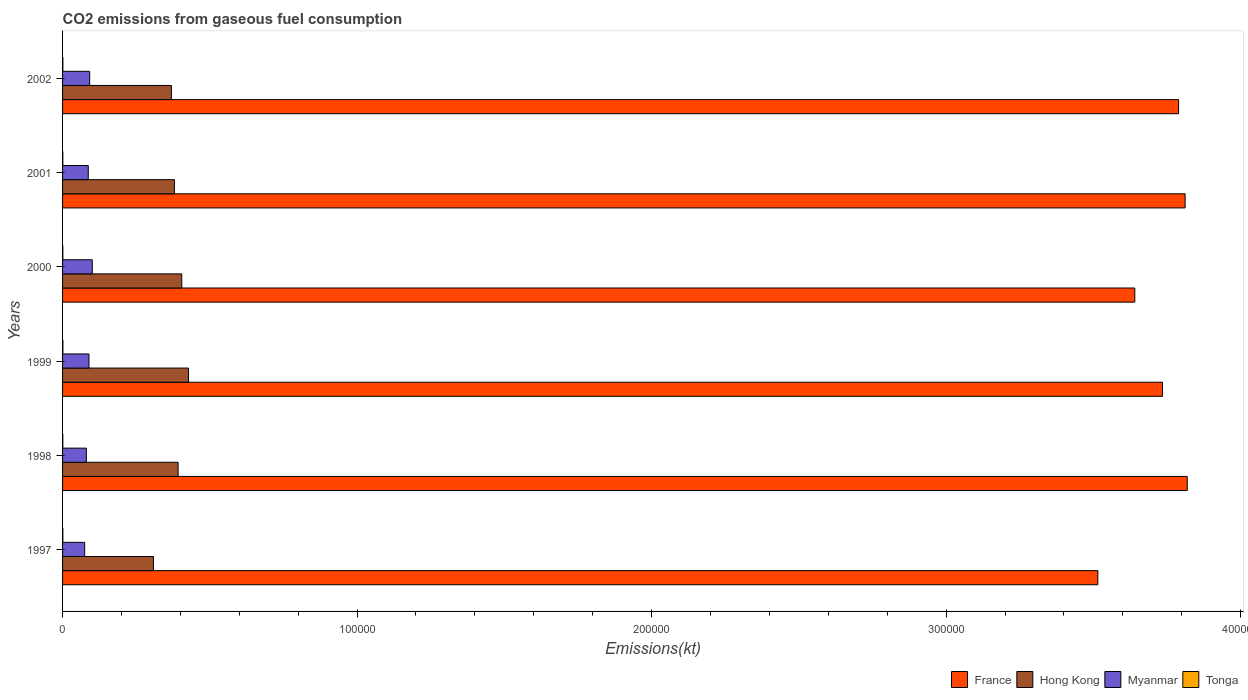How many different coloured bars are there?
Keep it short and to the point. 4. How many bars are there on the 4th tick from the top?
Your answer should be compact. 4. How many bars are there on the 6th tick from the bottom?
Offer a very short reply. 4. What is the label of the 6th group of bars from the top?
Your response must be concise. 1997. In how many cases, is the number of bars for a given year not equal to the number of legend labels?
Provide a short and direct response. 0. What is the amount of CO2 emitted in Myanmar in 2002?
Provide a short and direct response. 9207.84. Across all years, what is the maximum amount of CO2 emitted in Hong Kong?
Provide a short and direct response. 4.28e+04. Across all years, what is the minimum amount of CO2 emitted in Tonga?
Offer a terse response. 88.01. In which year was the amount of CO2 emitted in Hong Kong maximum?
Provide a succinct answer. 1999. In which year was the amount of CO2 emitted in Tonga minimum?
Offer a terse response. 1998. What is the total amount of CO2 emitted in Tonga in the graph?
Provide a succinct answer. 583.05. What is the difference between the amount of CO2 emitted in France in 1999 and that in 2002?
Give a very brief answer. -5467.5. What is the difference between the amount of CO2 emitted in Tonga in 1999 and the amount of CO2 emitted in France in 2002?
Your answer should be very brief. -3.79e+05. What is the average amount of CO2 emitted in Myanmar per year?
Keep it short and to the point. 8761.07. In the year 1998, what is the difference between the amount of CO2 emitted in Hong Kong and amount of CO2 emitted in France?
Offer a very short reply. -3.43e+05. What is the ratio of the amount of CO2 emitted in France in 2001 to that in 2002?
Give a very brief answer. 1.01. Is the amount of CO2 emitted in France in 1999 less than that in 2000?
Provide a short and direct response. No. What is the difference between the highest and the second highest amount of CO2 emitted in France?
Ensure brevity in your answer.  722.4. What is the difference between the highest and the lowest amount of CO2 emitted in Hong Kong?
Provide a succinct answer. 1.19e+04. Is the sum of the amount of CO2 emitted in Myanmar in 1998 and 2002 greater than the maximum amount of CO2 emitted in Hong Kong across all years?
Your answer should be very brief. No. Is it the case that in every year, the sum of the amount of CO2 emitted in Tonga and amount of CO2 emitted in France is greater than the sum of amount of CO2 emitted in Myanmar and amount of CO2 emitted in Hong Kong?
Provide a succinct answer. No. What does the 2nd bar from the top in 2000 represents?
Provide a succinct answer. Myanmar. What does the 2nd bar from the bottom in 2001 represents?
Ensure brevity in your answer.  Hong Kong. How many bars are there?
Keep it short and to the point. 24. Are all the bars in the graph horizontal?
Offer a very short reply. Yes. How many years are there in the graph?
Ensure brevity in your answer.  6. Does the graph contain any zero values?
Your answer should be very brief. No. Does the graph contain grids?
Your answer should be very brief. No. What is the title of the graph?
Your answer should be compact. CO2 emissions from gaseous fuel consumption. Does "Gabon" appear as one of the legend labels in the graph?
Offer a very short reply. No. What is the label or title of the X-axis?
Offer a very short reply. Emissions(kt). What is the Emissions(kt) in France in 1997?
Your answer should be compact. 3.52e+05. What is the Emissions(kt) in Hong Kong in 1997?
Provide a succinct answer. 3.09e+04. What is the Emissions(kt) of Myanmar in 1997?
Keep it short and to the point. 7499.02. What is the Emissions(kt) of Tonga in 1997?
Offer a very short reply. 99.01. What is the Emissions(kt) of France in 1998?
Your response must be concise. 3.82e+05. What is the Emissions(kt) of Hong Kong in 1998?
Your answer should be very brief. 3.92e+04. What is the Emissions(kt) in Myanmar in 1998?
Keep it short and to the point. 8078.4. What is the Emissions(kt) of Tonga in 1998?
Give a very brief answer. 88.01. What is the Emissions(kt) of France in 1999?
Your answer should be very brief. 3.73e+05. What is the Emissions(kt) of Hong Kong in 1999?
Provide a succinct answer. 4.28e+04. What is the Emissions(kt) of Myanmar in 1999?
Your answer should be very brief. 8969.48. What is the Emissions(kt) of Tonga in 1999?
Keep it short and to the point. 110.01. What is the Emissions(kt) of France in 2000?
Your answer should be very brief. 3.64e+05. What is the Emissions(kt) in Hong Kong in 2000?
Keep it short and to the point. 4.05e+04. What is the Emissions(kt) of Myanmar in 2000?
Offer a terse response. 1.01e+04. What is the Emissions(kt) of Tonga in 2000?
Offer a very short reply. 95.34. What is the Emissions(kt) of France in 2001?
Keep it short and to the point. 3.81e+05. What is the Emissions(kt) of Hong Kong in 2001?
Offer a terse response. 3.80e+04. What is the Emissions(kt) in Myanmar in 2001?
Your answer should be compact. 8723.79. What is the Emissions(kt) of Tonga in 2001?
Offer a terse response. 88.01. What is the Emissions(kt) in France in 2002?
Give a very brief answer. 3.79e+05. What is the Emissions(kt) in Hong Kong in 2002?
Your response must be concise. 3.70e+04. What is the Emissions(kt) in Myanmar in 2002?
Your answer should be very brief. 9207.84. What is the Emissions(kt) in Tonga in 2002?
Ensure brevity in your answer.  102.68. Across all years, what is the maximum Emissions(kt) in France?
Provide a succinct answer. 3.82e+05. Across all years, what is the maximum Emissions(kt) in Hong Kong?
Your answer should be compact. 4.28e+04. Across all years, what is the maximum Emissions(kt) in Myanmar?
Offer a very short reply. 1.01e+04. Across all years, what is the maximum Emissions(kt) of Tonga?
Provide a short and direct response. 110.01. Across all years, what is the minimum Emissions(kt) of France?
Offer a terse response. 3.52e+05. Across all years, what is the minimum Emissions(kt) of Hong Kong?
Your answer should be very brief. 3.09e+04. Across all years, what is the minimum Emissions(kt) in Myanmar?
Provide a short and direct response. 7499.02. Across all years, what is the minimum Emissions(kt) in Tonga?
Ensure brevity in your answer.  88.01. What is the total Emissions(kt) in France in the graph?
Provide a succinct answer. 2.23e+06. What is the total Emissions(kt) of Hong Kong in the graph?
Provide a succinct answer. 2.28e+05. What is the total Emissions(kt) of Myanmar in the graph?
Provide a succinct answer. 5.26e+04. What is the total Emissions(kt) in Tonga in the graph?
Provide a succinct answer. 583.05. What is the difference between the Emissions(kt) in France in 1997 and that in 1998?
Keep it short and to the point. -3.04e+04. What is the difference between the Emissions(kt) in Hong Kong in 1997 and that in 1998?
Offer a terse response. -8379.09. What is the difference between the Emissions(kt) of Myanmar in 1997 and that in 1998?
Offer a terse response. -579.39. What is the difference between the Emissions(kt) of Tonga in 1997 and that in 1998?
Your answer should be compact. 11. What is the difference between the Emissions(kt) of France in 1997 and that in 1999?
Offer a terse response. -2.20e+04. What is the difference between the Emissions(kt) in Hong Kong in 1997 and that in 1999?
Provide a short and direct response. -1.19e+04. What is the difference between the Emissions(kt) in Myanmar in 1997 and that in 1999?
Keep it short and to the point. -1470.47. What is the difference between the Emissions(kt) in Tonga in 1997 and that in 1999?
Provide a succinct answer. -11. What is the difference between the Emissions(kt) of France in 1997 and that in 2000?
Your response must be concise. -1.26e+04. What is the difference between the Emissions(kt) of Hong Kong in 1997 and that in 2000?
Make the answer very short. -9611.21. What is the difference between the Emissions(kt) of Myanmar in 1997 and that in 2000?
Keep it short and to the point. -2588.9. What is the difference between the Emissions(kt) in Tonga in 1997 and that in 2000?
Keep it short and to the point. 3.67. What is the difference between the Emissions(kt) of France in 1997 and that in 2001?
Make the answer very short. -2.96e+04. What is the difference between the Emissions(kt) in Hong Kong in 1997 and that in 2001?
Your response must be concise. -7117.65. What is the difference between the Emissions(kt) in Myanmar in 1997 and that in 2001?
Keep it short and to the point. -1224.78. What is the difference between the Emissions(kt) in Tonga in 1997 and that in 2001?
Offer a very short reply. 11. What is the difference between the Emissions(kt) of France in 1997 and that in 2002?
Make the answer very short. -2.74e+04. What is the difference between the Emissions(kt) in Hong Kong in 1997 and that in 2002?
Offer a terse response. -6098.22. What is the difference between the Emissions(kt) of Myanmar in 1997 and that in 2002?
Offer a terse response. -1708.82. What is the difference between the Emissions(kt) in Tonga in 1997 and that in 2002?
Make the answer very short. -3.67. What is the difference between the Emissions(kt) in France in 1998 and that in 1999?
Your answer should be compact. 8415.76. What is the difference between the Emissions(kt) in Hong Kong in 1998 and that in 1999?
Make the answer very short. -3520.32. What is the difference between the Emissions(kt) in Myanmar in 1998 and that in 1999?
Make the answer very short. -891.08. What is the difference between the Emissions(kt) in Tonga in 1998 and that in 1999?
Give a very brief answer. -22. What is the difference between the Emissions(kt) of France in 1998 and that in 2000?
Your response must be concise. 1.78e+04. What is the difference between the Emissions(kt) of Hong Kong in 1998 and that in 2000?
Your response must be concise. -1232.11. What is the difference between the Emissions(kt) in Myanmar in 1998 and that in 2000?
Provide a succinct answer. -2009.52. What is the difference between the Emissions(kt) of Tonga in 1998 and that in 2000?
Your answer should be very brief. -7.33. What is the difference between the Emissions(kt) in France in 1998 and that in 2001?
Your response must be concise. 722.4. What is the difference between the Emissions(kt) of Hong Kong in 1998 and that in 2001?
Ensure brevity in your answer.  1261.45. What is the difference between the Emissions(kt) in Myanmar in 1998 and that in 2001?
Your answer should be compact. -645.39. What is the difference between the Emissions(kt) in Tonga in 1998 and that in 2001?
Your answer should be very brief. 0. What is the difference between the Emissions(kt) in France in 1998 and that in 2002?
Make the answer very short. 2948.27. What is the difference between the Emissions(kt) in Hong Kong in 1998 and that in 2002?
Keep it short and to the point. 2280.87. What is the difference between the Emissions(kt) in Myanmar in 1998 and that in 2002?
Offer a terse response. -1129.44. What is the difference between the Emissions(kt) in Tonga in 1998 and that in 2002?
Give a very brief answer. -14.67. What is the difference between the Emissions(kt) of France in 1999 and that in 2000?
Offer a terse response. 9398.52. What is the difference between the Emissions(kt) in Hong Kong in 1999 and that in 2000?
Provide a short and direct response. 2288.21. What is the difference between the Emissions(kt) of Myanmar in 1999 and that in 2000?
Provide a short and direct response. -1118.43. What is the difference between the Emissions(kt) in Tonga in 1999 and that in 2000?
Offer a very short reply. 14.67. What is the difference between the Emissions(kt) in France in 1999 and that in 2001?
Offer a very short reply. -7693.37. What is the difference between the Emissions(kt) in Hong Kong in 1999 and that in 2001?
Offer a very short reply. 4781.77. What is the difference between the Emissions(kt) in Myanmar in 1999 and that in 2001?
Offer a very short reply. 245.69. What is the difference between the Emissions(kt) of Tonga in 1999 and that in 2001?
Provide a short and direct response. 22. What is the difference between the Emissions(kt) of France in 1999 and that in 2002?
Keep it short and to the point. -5467.5. What is the difference between the Emissions(kt) of Hong Kong in 1999 and that in 2002?
Ensure brevity in your answer.  5801.19. What is the difference between the Emissions(kt) in Myanmar in 1999 and that in 2002?
Your answer should be compact. -238.35. What is the difference between the Emissions(kt) of Tonga in 1999 and that in 2002?
Offer a terse response. 7.33. What is the difference between the Emissions(kt) of France in 2000 and that in 2001?
Your answer should be very brief. -1.71e+04. What is the difference between the Emissions(kt) in Hong Kong in 2000 and that in 2001?
Ensure brevity in your answer.  2493.56. What is the difference between the Emissions(kt) of Myanmar in 2000 and that in 2001?
Ensure brevity in your answer.  1364.12. What is the difference between the Emissions(kt) of Tonga in 2000 and that in 2001?
Your response must be concise. 7.33. What is the difference between the Emissions(kt) in France in 2000 and that in 2002?
Provide a succinct answer. -1.49e+04. What is the difference between the Emissions(kt) of Hong Kong in 2000 and that in 2002?
Offer a terse response. 3512.99. What is the difference between the Emissions(kt) in Myanmar in 2000 and that in 2002?
Ensure brevity in your answer.  880.08. What is the difference between the Emissions(kt) of Tonga in 2000 and that in 2002?
Provide a short and direct response. -7.33. What is the difference between the Emissions(kt) of France in 2001 and that in 2002?
Make the answer very short. 2225.87. What is the difference between the Emissions(kt) in Hong Kong in 2001 and that in 2002?
Make the answer very short. 1019.43. What is the difference between the Emissions(kt) in Myanmar in 2001 and that in 2002?
Your response must be concise. -484.04. What is the difference between the Emissions(kt) of Tonga in 2001 and that in 2002?
Your response must be concise. -14.67. What is the difference between the Emissions(kt) of France in 1997 and the Emissions(kt) of Hong Kong in 1998?
Your answer should be very brief. 3.12e+05. What is the difference between the Emissions(kt) in France in 1997 and the Emissions(kt) in Myanmar in 1998?
Your answer should be very brief. 3.43e+05. What is the difference between the Emissions(kt) of France in 1997 and the Emissions(kt) of Tonga in 1998?
Your answer should be very brief. 3.51e+05. What is the difference between the Emissions(kt) of Hong Kong in 1997 and the Emissions(kt) of Myanmar in 1998?
Your answer should be very brief. 2.28e+04. What is the difference between the Emissions(kt) of Hong Kong in 1997 and the Emissions(kt) of Tonga in 1998?
Give a very brief answer. 3.08e+04. What is the difference between the Emissions(kt) in Myanmar in 1997 and the Emissions(kt) in Tonga in 1998?
Offer a terse response. 7411.01. What is the difference between the Emissions(kt) in France in 1997 and the Emissions(kt) in Hong Kong in 1999?
Keep it short and to the point. 3.09e+05. What is the difference between the Emissions(kt) of France in 1997 and the Emissions(kt) of Myanmar in 1999?
Provide a succinct answer. 3.43e+05. What is the difference between the Emissions(kt) in France in 1997 and the Emissions(kt) in Tonga in 1999?
Ensure brevity in your answer.  3.51e+05. What is the difference between the Emissions(kt) in Hong Kong in 1997 and the Emissions(kt) in Myanmar in 1999?
Give a very brief answer. 2.19e+04. What is the difference between the Emissions(kt) of Hong Kong in 1997 and the Emissions(kt) of Tonga in 1999?
Give a very brief answer. 3.07e+04. What is the difference between the Emissions(kt) in Myanmar in 1997 and the Emissions(kt) in Tonga in 1999?
Your response must be concise. 7389.01. What is the difference between the Emissions(kt) in France in 1997 and the Emissions(kt) in Hong Kong in 2000?
Your answer should be very brief. 3.11e+05. What is the difference between the Emissions(kt) of France in 1997 and the Emissions(kt) of Myanmar in 2000?
Give a very brief answer. 3.41e+05. What is the difference between the Emissions(kt) of France in 1997 and the Emissions(kt) of Tonga in 2000?
Offer a very short reply. 3.51e+05. What is the difference between the Emissions(kt) of Hong Kong in 1997 and the Emissions(kt) of Myanmar in 2000?
Your answer should be very brief. 2.08e+04. What is the difference between the Emissions(kt) in Hong Kong in 1997 and the Emissions(kt) in Tonga in 2000?
Keep it short and to the point. 3.08e+04. What is the difference between the Emissions(kt) of Myanmar in 1997 and the Emissions(kt) of Tonga in 2000?
Make the answer very short. 7403.67. What is the difference between the Emissions(kt) in France in 1997 and the Emissions(kt) in Hong Kong in 2001?
Keep it short and to the point. 3.14e+05. What is the difference between the Emissions(kt) in France in 1997 and the Emissions(kt) in Myanmar in 2001?
Your answer should be compact. 3.43e+05. What is the difference between the Emissions(kt) in France in 1997 and the Emissions(kt) in Tonga in 2001?
Keep it short and to the point. 3.51e+05. What is the difference between the Emissions(kt) in Hong Kong in 1997 and the Emissions(kt) in Myanmar in 2001?
Your answer should be very brief. 2.21e+04. What is the difference between the Emissions(kt) in Hong Kong in 1997 and the Emissions(kt) in Tonga in 2001?
Offer a terse response. 3.08e+04. What is the difference between the Emissions(kt) of Myanmar in 1997 and the Emissions(kt) of Tonga in 2001?
Your answer should be compact. 7411.01. What is the difference between the Emissions(kt) in France in 1997 and the Emissions(kt) in Hong Kong in 2002?
Ensure brevity in your answer.  3.15e+05. What is the difference between the Emissions(kt) in France in 1997 and the Emissions(kt) in Myanmar in 2002?
Your answer should be compact. 3.42e+05. What is the difference between the Emissions(kt) in France in 1997 and the Emissions(kt) in Tonga in 2002?
Keep it short and to the point. 3.51e+05. What is the difference between the Emissions(kt) of Hong Kong in 1997 and the Emissions(kt) of Myanmar in 2002?
Your response must be concise. 2.16e+04. What is the difference between the Emissions(kt) in Hong Kong in 1997 and the Emissions(kt) in Tonga in 2002?
Keep it short and to the point. 3.08e+04. What is the difference between the Emissions(kt) in Myanmar in 1997 and the Emissions(kt) in Tonga in 2002?
Provide a short and direct response. 7396.34. What is the difference between the Emissions(kt) in France in 1998 and the Emissions(kt) in Hong Kong in 1999?
Provide a succinct answer. 3.39e+05. What is the difference between the Emissions(kt) of France in 1998 and the Emissions(kt) of Myanmar in 1999?
Provide a short and direct response. 3.73e+05. What is the difference between the Emissions(kt) of France in 1998 and the Emissions(kt) of Tonga in 1999?
Your answer should be compact. 3.82e+05. What is the difference between the Emissions(kt) of Hong Kong in 1998 and the Emissions(kt) of Myanmar in 1999?
Ensure brevity in your answer.  3.03e+04. What is the difference between the Emissions(kt) in Hong Kong in 1998 and the Emissions(kt) in Tonga in 1999?
Ensure brevity in your answer.  3.91e+04. What is the difference between the Emissions(kt) of Myanmar in 1998 and the Emissions(kt) of Tonga in 1999?
Offer a very short reply. 7968.39. What is the difference between the Emissions(kt) in France in 1998 and the Emissions(kt) in Hong Kong in 2000?
Your answer should be compact. 3.41e+05. What is the difference between the Emissions(kt) in France in 1998 and the Emissions(kt) in Myanmar in 2000?
Offer a terse response. 3.72e+05. What is the difference between the Emissions(kt) in France in 1998 and the Emissions(kt) in Tonga in 2000?
Provide a short and direct response. 3.82e+05. What is the difference between the Emissions(kt) of Hong Kong in 1998 and the Emissions(kt) of Myanmar in 2000?
Offer a terse response. 2.91e+04. What is the difference between the Emissions(kt) of Hong Kong in 1998 and the Emissions(kt) of Tonga in 2000?
Keep it short and to the point. 3.91e+04. What is the difference between the Emissions(kt) of Myanmar in 1998 and the Emissions(kt) of Tonga in 2000?
Your answer should be very brief. 7983.06. What is the difference between the Emissions(kt) in France in 1998 and the Emissions(kt) in Hong Kong in 2001?
Make the answer very short. 3.44e+05. What is the difference between the Emissions(kt) in France in 1998 and the Emissions(kt) in Myanmar in 2001?
Give a very brief answer. 3.73e+05. What is the difference between the Emissions(kt) of France in 1998 and the Emissions(kt) of Tonga in 2001?
Your answer should be compact. 3.82e+05. What is the difference between the Emissions(kt) in Hong Kong in 1998 and the Emissions(kt) in Myanmar in 2001?
Your answer should be compact. 3.05e+04. What is the difference between the Emissions(kt) of Hong Kong in 1998 and the Emissions(kt) of Tonga in 2001?
Ensure brevity in your answer.  3.91e+04. What is the difference between the Emissions(kt) of Myanmar in 1998 and the Emissions(kt) of Tonga in 2001?
Provide a succinct answer. 7990.39. What is the difference between the Emissions(kt) in France in 1998 and the Emissions(kt) in Hong Kong in 2002?
Ensure brevity in your answer.  3.45e+05. What is the difference between the Emissions(kt) in France in 1998 and the Emissions(kt) in Myanmar in 2002?
Make the answer very short. 3.73e+05. What is the difference between the Emissions(kt) in France in 1998 and the Emissions(kt) in Tonga in 2002?
Provide a short and direct response. 3.82e+05. What is the difference between the Emissions(kt) in Hong Kong in 1998 and the Emissions(kt) in Myanmar in 2002?
Give a very brief answer. 3.00e+04. What is the difference between the Emissions(kt) of Hong Kong in 1998 and the Emissions(kt) of Tonga in 2002?
Make the answer very short. 3.91e+04. What is the difference between the Emissions(kt) in Myanmar in 1998 and the Emissions(kt) in Tonga in 2002?
Provide a short and direct response. 7975.73. What is the difference between the Emissions(kt) in France in 1999 and the Emissions(kt) in Hong Kong in 2000?
Offer a terse response. 3.33e+05. What is the difference between the Emissions(kt) of France in 1999 and the Emissions(kt) of Myanmar in 2000?
Your answer should be very brief. 3.63e+05. What is the difference between the Emissions(kt) of France in 1999 and the Emissions(kt) of Tonga in 2000?
Provide a short and direct response. 3.73e+05. What is the difference between the Emissions(kt) of Hong Kong in 1999 and the Emissions(kt) of Myanmar in 2000?
Your answer should be compact. 3.27e+04. What is the difference between the Emissions(kt) of Hong Kong in 1999 and the Emissions(kt) of Tonga in 2000?
Offer a very short reply. 4.27e+04. What is the difference between the Emissions(kt) in Myanmar in 1999 and the Emissions(kt) in Tonga in 2000?
Your answer should be very brief. 8874.14. What is the difference between the Emissions(kt) of France in 1999 and the Emissions(kt) of Hong Kong in 2001?
Your answer should be compact. 3.35e+05. What is the difference between the Emissions(kt) in France in 1999 and the Emissions(kt) in Myanmar in 2001?
Provide a short and direct response. 3.65e+05. What is the difference between the Emissions(kt) in France in 1999 and the Emissions(kt) in Tonga in 2001?
Offer a terse response. 3.73e+05. What is the difference between the Emissions(kt) of Hong Kong in 1999 and the Emissions(kt) of Myanmar in 2001?
Your answer should be compact. 3.40e+04. What is the difference between the Emissions(kt) of Hong Kong in 1999 and the Emissions(kt) of Tonga in 2001?
Your response must be concise. 4.27e+04. What is the difference between the Emissions(kt) of Myanmar in 1999 and the Emissions(kt) of Tonga in 2001?
Provide a short and direct response. 8881.47. What is the difference between the Emissions(kt) in France in 1999 and the Emissions(kt) in Hong Kong in 2002?
Provide a succinct answer. 3.37e+05. What is the difference between the Emissions(kt) in France in 1999 and the Emissions(kt) in Myanmar in 2002?
Ensure brevity in your answer.  3.64e+05. What is the difference between the Emissions(kt) of France in 1999 and the Emissions(kt) of Tonga in 2002?
Your answer should be very brief. 3.73e+05. What is the difference between the Emissions(kt) of Hong Kong in 1999 and the Emissions(kt) of Myanmar in 2002?
Your answer should be very brief. 3.35e+04. What is the difference between the Emissions(kt) in Hong Kong in 1999 and the Emissions(kt) in Tonga in 2002?
Make the answer very short. 4.27e+04. What is the difference between the Emissions(kt) in Myanmar in 1999 and the Emissions(kt) in Tonga in 2002?
Your answer should be compact. 8866.81. What is the difference between the Emissions(kt) in France in 2000 and the Emissions(kt) in Hong Kong in 2001?
Offer a very short reply. 3.26e+05. What is the difference between the Emissions(kt) of France in 2000 and the Emissions(kt) of Myanmar in 2001?
Keep it short and to the point. 3.55e+05. What is the difference between the Emissions(kt) in France in 2000 and the Emissions(kt) in Tonga in 2001?
Give a very brief answer. 3.64e+05. What is the difference between the Emissions(kt) in Hong Kong in 2000 and the Emissions(kt) in Myanmar in 2001?
Keep it short and to the point. 3.17e+04. What is the difference between the Emissions(kt) of Hong Kong in 2000 and the Emissions(kt) of Tonga in 2001?
Provide a short and direct response. 4.04e+04. What is the difference between the Emissions(kt) of Myanmar in 2000 and the Emissions(kt) of Tonga in 2001?
Your response must be concise. 9999.91. What is the difference between the Emissions(kt) of France in 2000 and the Emissions(kt) of Hong Kong in 2002?
Provide a short and direct response. 3.27e+05. What is the difference between the Emissions(kt) of France in 2000 and the Emissions(kt) of Myanmar in 2002?
Offer a very short reply. 3.55e+05. What is the difference between the Emissions(kt) of France in 2000 and the Emissions(kt) of Tonga in 2002?
Your response must be concise. 3.64e+05. What is the difference between the Emissions(kt) in Hong Kong in 2000 and the Emissions(kt) in Myanmar in 2002?
Give a very brief answer. 3.13e+04. What is the difference between the Emissions(kt) of Hong Kong in 2000 and the Emissions(kt) of Tonga in 2002?
Keep it short and to the point. 4.04e+04. What is the difference between the Emissions(kt) in Myanmar in 2000 and the Emissions(kt) in Tonga in 2002?
Provide a short and direct response. 9985.24. What is the difference between the Emissions(kt) of France in 2001 and the Emissions(kt) of Hong Kong in 2002?
Provide a succinct answer. 3.44e+05. What is the difference between the Emissions(kt) of France in 2001 and the Emissions(kt) of Myanmar in 2002?
Provide a short and direct response. 3.72e+05. What is the difference between the Emissions(kt) of France in 2001 and the Emissions(kt) of Tonga in 2002?
Your answer should be compact. 3.81e+05. What is the difference between the Emissions(kt) of Hong Kong in 2001 and the Emissions(kt) of Myanmar in 2002?
Offer a terse response. 2.88e+04. What is the difference between the Emissions(kt) in Hong Kong in 2001 and the Emissions(kt) in Tonga in 2002?
Provide a succinct answer. 3.79e+04. What is the difference between the Emissions(kt) in Myanmar in 2001 and the Emissions(kt) in Tonga in 2002?
Your answer should be very brief. 8621.12. What is the average Emissions(kt) of France per year?
Keep it short and to the point. 3.72e+05. What is the average Emissions(kt) in Hong Kong per year?
Provide a succinct answer. 3.80e+04. What is the average Emissions(kt) of Myanmar per year?
Make the answer very short. 8761.07. What is the average Emissions(kt) of Tonga per year?
Keep it short and to the point. 97.18. In the year 1997, what is the difference between the Emissions(kt) in France and Emissions(kt) in Hong Kong?
Give a very brief answer. 3.21e+05. In the year 1997, what is the difference between the Emissions(kt) in France and Emissions(kt) in Myanmar?
Offer a terse response. 3.44e+05. In the year 1997, what is the difference between the Emissions(kt) of France and Emissions(kt) of Tonga?
Ensure brevity in your answer.  3.51e+05. In the year 1997, what is the difference between the Emissions(kt) of Hong Kong and Emissions(kt) of Myanmar?
Give a very brief answer. 2.34e+04. In the year 1997, what is the difference between the Emissions(kt) of Hong Kong and Emissions(kt) of Tonga?
Provide a succinct answer. 3.08e+04. In the year 1997, what is the difference between the Emissions(kt) in Myanmar and Emissions(kt) in Tonga?
Ensure brevity in your answer.  7400.01. In the year 1998, what is the difference between the Emissions(kt) in France and Emissions(kt) in Hong Kong?
Your response must be concise. 3.43e+05. In the year 1998, what is the difference between the Emissions(kt) in France and Emissions(kt) in Myanmar?
Your answer should be compact. 3.74e+05. In the year 1998, what is the difference between the Emissions(kt) of France and Emissions(kt) of Tonga?
Give a very brief answer. 3.82e+05. In the year 1998, what is the difference between the Emissions(kt) of Hong Kong and Emissions(kt) of Myanmar?
Your answer should be compact. 3.12e+04. In the year 1998, what is the difference between the Emissions(kt) of Hong Kong and Emissions(kt) of Tonga?
Your response must be concise. 3.91e+04. In the year 1998, what is the difference between the Emissions(kt) in Myanmar and Emissions(kt) in Tonga?
Your answer should be compact. 7990.39. In the year 1999, what is the difference between the Emissions(kt) of France and Emissions(kt) of Hong Kong?
Provide a short and direct response. 3.31e+05. In the year 1999, what is the difference between the Emissions(kt) in France and Emissions(kt) in Myanmar?
Ensure brevity in your answer.  3.64e+05. In the year 1999, what is the difference between the Emissions(kt) of France and Emissions(kt) of Tonga?
Ensure brevity in your answer.  3.73e+05. In the year 1999, what is the difference between the Emissions(kt) of Hong Kong and Emissions(kt) of Myanmar?
Provide a succinct answer. 3.38e+04. In the year 1999, what is the difference between the Emissions(kt) of Hong Kong and Emissions(kt) of Tonga?
Give a very brief answer. 4.26e+04. In the year 1999, what is the difference between the Emissions(kt) in Myanmar and Emissions(kt) in Tonga?
Your answer should be compact. 8859.47. In the year 2000, what is the difference between the Emissions(kt) in France and Emissions(kt) in Hong Kong?
Your response must be concise. 3.24e+05. In the year 2000, what is the difference between the Emissions(kt) of France and Emissions(kt) of Myanmar?
Your answer should be very brief. 3.54e+05. In the year 2000, what is the difference between the Emissions(kt) in France and Emissions(kt) in Tonga?
Offer a very short reply. 3.64e+05. In the year 2000, what is the difference between the Emissions(kt) in Hong Kong and Emissions(kt) in Myanmar?
Make the answer very short. 3.04e+04. In the year 2000, what is the difference between the Emissions(kt) in Hong Kong and Emissions(kt) in Tonga?
Offer a terse response. 4.04e+04. In the year 2000, what is the difference between the Emissions(kt) of Myanmar and Emissions(kt) of Tonga?
Provide a short and direct response. 9992.58. In the year 2001, what is the difference between the Emissions(kt) in France and Emissions(kt) in Hong Kong?
Ensure brevity in your answer.  3.43e+05. In the year 2001, what is the difference between the Emissions(kt) in France and Emissions(kt) in Myanmar?
Give a very brief answer. 3.72e+05. In the year 2001, what is the difference between the Emissions(kt) of France and Emissions(kt) of Tonga?
Offer a terse response. 3.81e+05. In the year 2001, what is the difference between the Emissions(kt) of Hong Kong and Emissions(kt) of Myanmar?
Give a very brief answer. 2.92e+04. In the year 2001, what is the difference between the Emissions(kt) in Hong Kong and Emissions(kt) in Tonga?
Make the answer very short. 3.79e+04. In the year 2001, what is the difference between the Emissions(kt) of Myanmar and Emissions(kt) of Tonga?
Offer a terse response. 8635.78. In the year 2002, what is the difference between the Emissions(kt) in France and Emissions(kt) in Hong Kong?
Offer a terse response. 3.42e+05. In the year 2002, what is the difference between the Emissions(kt) in France and Emissions(kt) in Myanmar?
Your answer should be very brief. 3.70e+05. In the year 2002, what is the difference between the Emissions(kt) of France and Emissions(kt) of Tonga?
Give a very brief answer. 3.79e+05. In the year 2002, what is the difference between the Emissions(kt) of Hong Kong and Emissions(kt) of Myanmar?
Offer a terse response. 2.77e+04. In the year 2002, what is the difference between the Emissions(kt) in Hong Kong and Emissions(kt) in Tonga?
Ensure brevity in your answer.  3.68e+04. In the year 2002, what is the difference between the Emissions(kt) in Myanmar and Emissions(kt) in Tonga?
Provide a short and direct response. 9105.16. What is the ratio of the Emissions(kt) in France in 1997 to that in 1998?
Provide a short and direct response. 0.92. What is the ratio of the Emissions(kt) in Hong Kong in 1997 to that in 1998?
Give a very brief answer. 0.79. What is the ratio of the Emissions(kt) in Myanmar in 1997 to that in 1998?
Offer a very short reply. 0.93. What is the ratio of the Emissions(kt) in Tonga in 1997 to that in 1998?
Provide a short and direct response. 1.12. What is the ratio of the Emissions(kt) in France in 1997 to that in 1999?
Your answer should be very brief. 0.94. What is the ratio of the Emissions(kt) in Hong Kong in 1997 to that in 1999?
Give a very brief answer. 0.72. What is the ratio of the Emissions(kt) in Myanmar in 1997 to that in 1999?
Make the answer very short. 0.84. What is the ratio of the Emissions(kt) in Tonga in 1997 to that in 1999?
Keep it short and to the point. 0.9. What is the ratio of the Emissions(kt) of France in 1997 to that in 2000?
Make the answer very short. 0.97. What is the ratio of the Emissions(kt) in Hong Kong in 1997 to that in 2000?
Your answer should be compact. 0.76. What is the ratio of the Emissions(kt) in Myanmar in 1997 to that in 2000?
Make the answer very short. 0.74. What is the ratio of the Emissions(kt) of France in 1997 to that in 2001?
Your response must be concise. 0.92. What is the ratio of the Emissions(kt) of Hong Kong in 1997 to that in 2001?
Offer a terse response. 0.81. What is the ratio of the Emissions(kt) of Myanmar in 1997 to that in 2001?
Make the answer very short. 0.86. What is the ratio of the Emissions(kt) in Tonga in 1997 to that in 2001?
Give a very brief answer. 1.12. What is the ratio of the Emissions(kt) of France in 1997 to that in 2002?
Your response must be concise. 0.93. What is the ratio of the Emissions(kt) of Hong Kong in 1997 to that in 2002?
Make the answer very short. 0.83. What is the ratio of the Emissions(kt) of Myanmar in 1997 to that in 2002?
Provide a succinct answer. 0.81. What is the ratio of the Emissions(kt) of France in 1998 to that in 1999?
Provide a short and direct response. 1.02. What is the ratio of the Emissions(kt) in Hong Kong in 1998 to that in 1999?
Offer a very short reply. 0.92. What is the ratio of the Emissions(kt) of Myanmar in 1998 to that in 1999?
Your answer should be very brief. 0.9. What is the ratio of the Emissions(kt) in France in 1998 to that in 2000?
Your answer should be very brief. 1.05. What is the ratio of the Emissions(kt) in Hong Kong in 1998 to that in 2000?
Give a very brief answer. 0.97. What is the ratio of the Emissions(kt) of Myanmar in 1998 to that in 2000?
Offer a terse response. 0.8. What is the ratio of the Emissions(kt) of Tonga in 1998 to that in 2000?
Provide a short and direct response. 0.92. What is the ratio of the Emissions(kt) of Hong Kong in 1998 to that in 2001?
Ensure brevity in your answer.  1.03. What is the ratio of the Emissions(kt) in Myanmar in 1998 to that in 2001?
Your response must be concise. 0.93. What is the ratio of the Emissions(kt) of Tonga in 1998 to that in 2001?
Your response must be concise. 1. What is the ratio of the Emissions(kt) in Hong Kong in 1998 to that in 2002?
Your answer should be very brief. 1.06. What is the ratio of the Emissions(kt) in Myanmar in 1998 to that in 2002?
Keep it short and to the point. 0.88. What is the ratio of the Emissions(kt) in France in 1999 to that in 2000?
Keep it short and to the point. 1.03. What is the ratio of the Emissions(kt) in Hong Kong in 1999 to that in 2000?
Your answer should be very brief. 1.06. What is the ratio of the Emissions(kt) in Myanmar in 1999 to that in 2000?
Offer a very short reply. 0.89. What is the ratio of the Emissions(kt) in Tonga in 1999 to that in 2000?
Your answer should be very brief. 1.15. What is the ratio of the Emissions(kt) in France in 1999 to that in 2001?
Offer a very short reply. 0.98. What is the ratio of the Emissions(kt) in Hong Kong in 1999 to that in 2001?
Offer a very short reply. 1.13. What is the ratio of the Emissions(kt) of Myanmar in 1999 to that in 2001?
Your answer should be compact. 1.03. What is the ratio of the Emissions(kt) in France in 1999 to that in 2002?
Give a very brief answer. 0.99. What is the ratio of the Emissions(kt) in Hong Kong in 1999 to that in 2002?
Your response must be concise. 1.16. What is the ratio of the Emissions(kt) in Myanmar in 1999 to that in 2002?
Provide a succinct answer. 0.97. What is the ratio of the Emissions(kt) of Tonga in 1999 to that in 2002?
Your answer should be compact. 1.07. What is the ratio of the Emissions(kt) of France in 2000 to that in 2001?
Ensure brevity in your answer.  0.96. What is the ratio of the Emissions(kt) of Hong Kong in 2000 to that in 2001?
Give a very brief answer. 1.07. What is the ratio of the Emissions(kt) in Myanmar in 2000 to that in 2001?
Ensure brevity in your answer.  1.16. What is the ratio of the Emissions(kt) in France in 2000 to that in 2002?
Provide a succinct answer. 0.96. What is the ratio of the Emissions(kt) in Hong Kong in 2000 to that in 2002?
Ensure brevity in your answer.  1.1. What is the ratio of the Emissions(kt) of Myanmar in 2000 to that in 2002?
Provide a succinct answer. 1.1. What is the ratio of the Emissions(kt) of France in 2001 to that in 2002?
Keep it short and to the point. 1.01. What is the ratio of the Emissions(kt) in Hong Kong in 2001 to that in 2002?
Your answer should be very brief. 1.03. What is the difference between the highest and the second highest Emissions(kt) of France?
Your answer should be very brief. 722.4. What is the difference between the highest and the second highest Emissions(kt) in Hong Kong?
Keep it short and to the point. 2288.21. What is the difference between the highest and the second highest Emissions(kt) in Myanmar?
Provide a short and direct response. 880.08. What is the difference between the highest and the second highest Emissions(kt) of Tonga?
Provide a short and direct response. 7.33. What is the difference between the highest and the lowest Emissions(kt) in France?
Offer a very short reply. 3.04e+04. What is the difference between the highest and the lowest Emissions(kt) in Hong Kong?
Provide a short and direct response. 1.19e+04. What is the difference between the highest and the lowest Emissions(kt) of Myanmar?
Provide a succinct answer. 2588.9. What is the difference between the highest and the lowest Emissions(kt) in Tonga?
Make the answer very short. 22. 